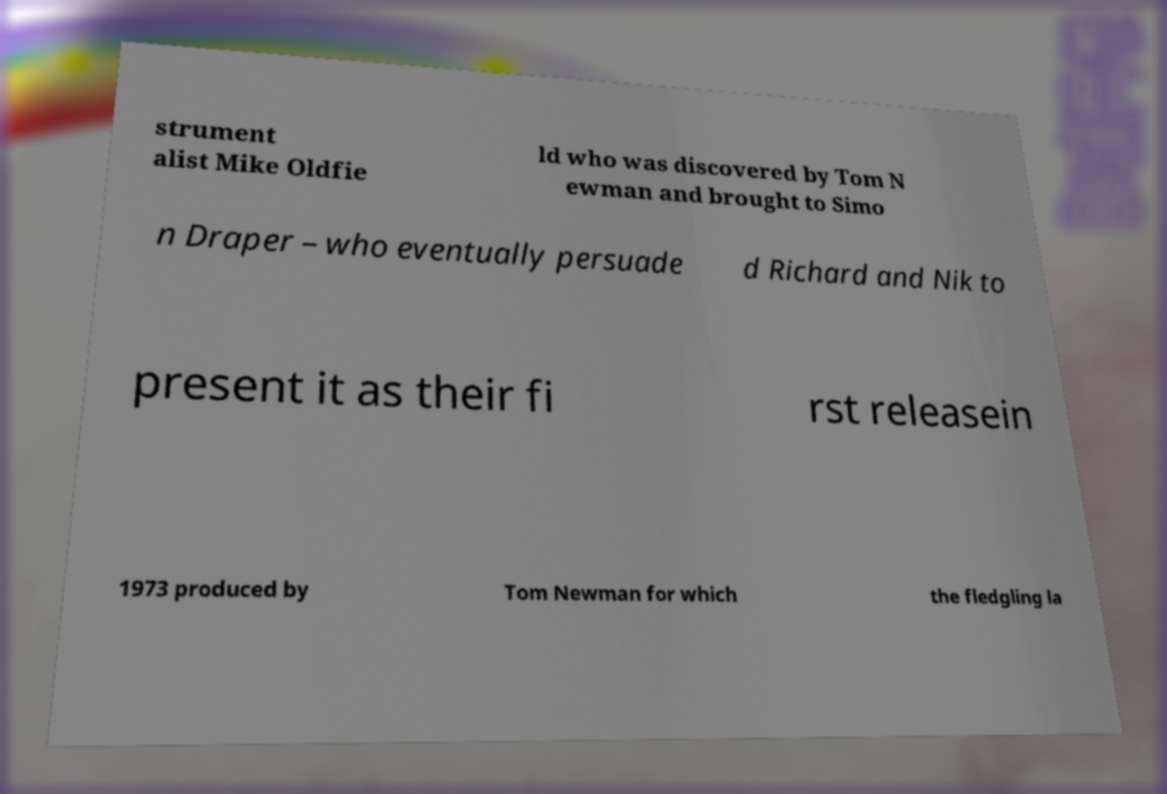Could you extract and type out the text from this image? strument alist Mike Oldfie ld who was discovered by Tom N ewman and brought to Simo n Draper – who eventually persuade d Richard and Nik to present it as their fi rst releasein 1973 produced by Tom Newman for which the fledgling la 